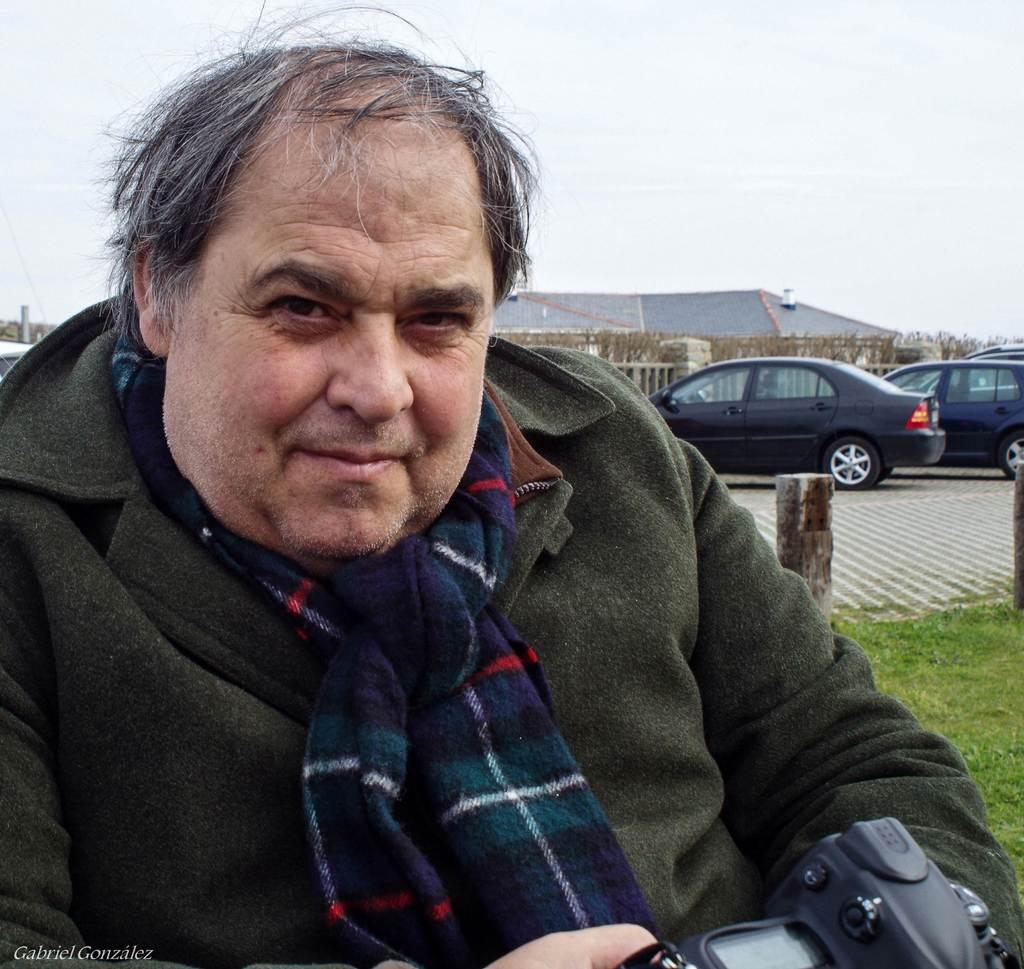What type of clothing is the man wearing around his neck in the image? The man is wearing a scarf in the image. What is the man holding in the image? The man is holding a camera in the image. What can be seen in the distance in the image? There are vehicles, a building, a fence, and trees in the distance. What is the color of the grass in the image? The grass is green in the image. What type of punishment is the man receiving in the image? There is no indication of punishment in the image; the man is simply wearing a jacket and a scarf, holding a camera, and standing in a grassy area with distant objects visible. 